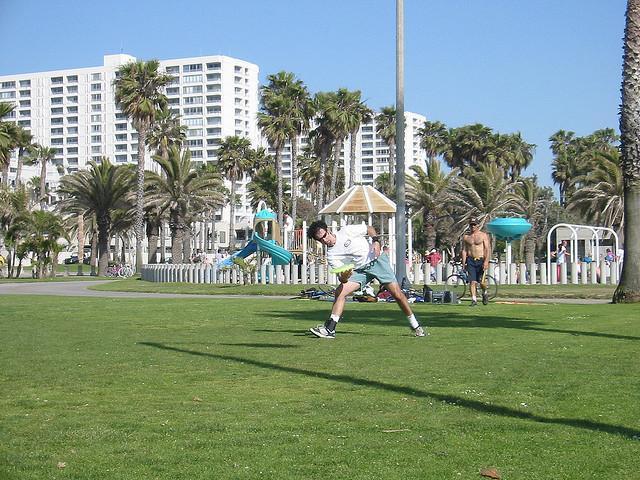How many cows have horns?
Give a very brief answer. 0. 